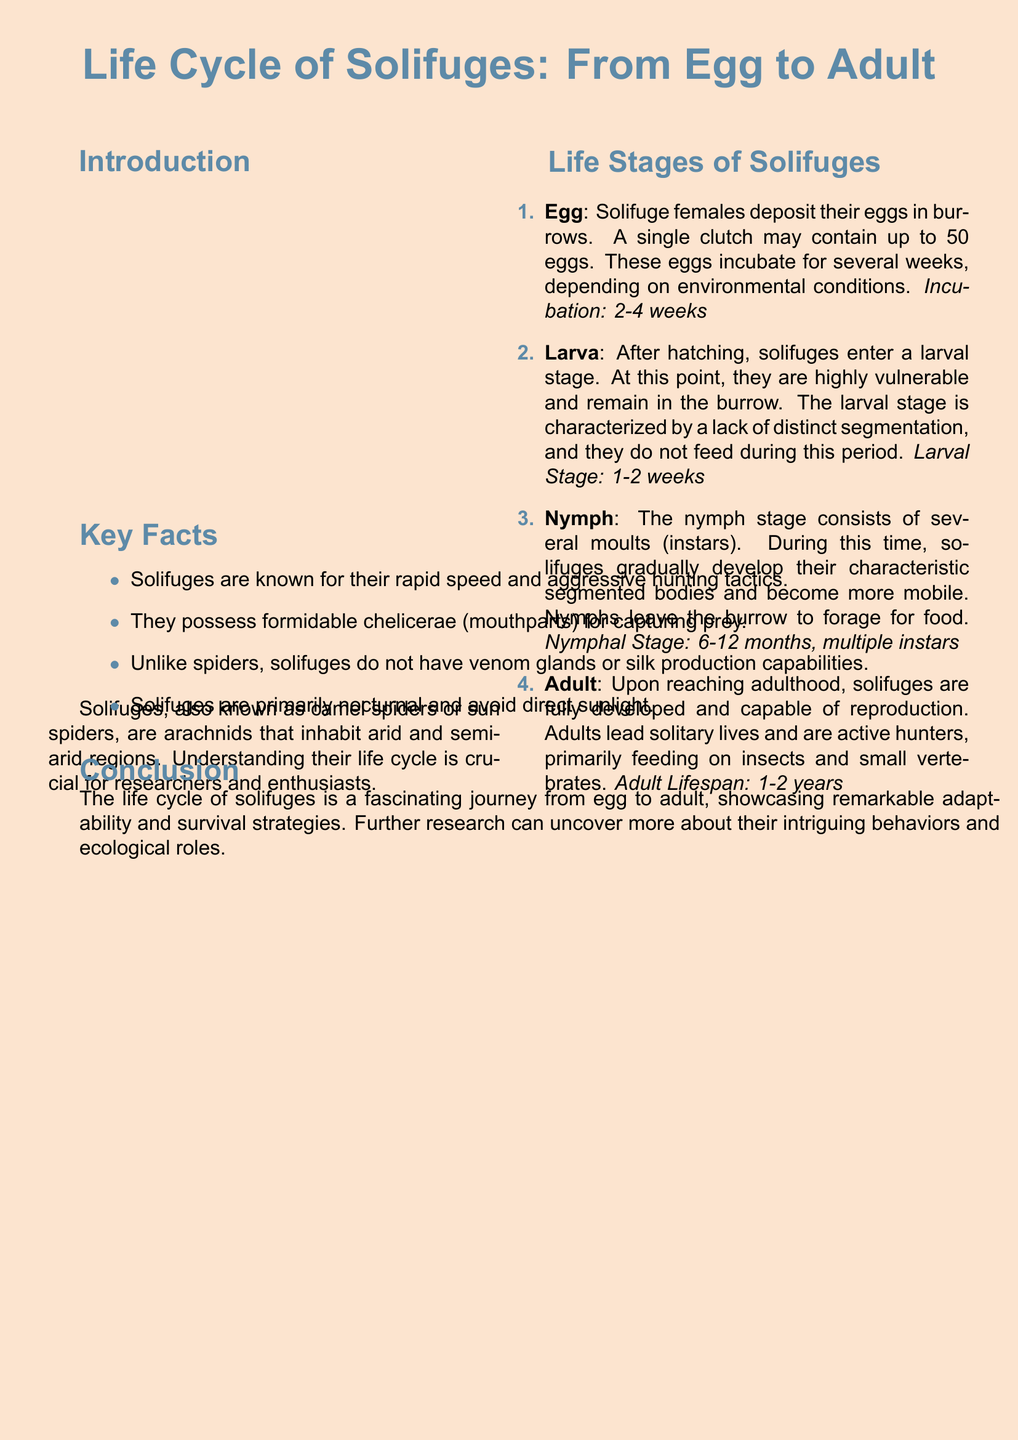what is the incubating period for solifuge eggs? The document states that the incubation period for solifuge eggs is 2-4 weeks.
Answer: 2-4 weeks how many eggs can a solifuge female lay in one clutch? According to the flyer, a single clutch may contain up to 50 eggs.
Answer: 50 eggs what is the larval stage duration for solifuges? The larval stage lasts for 1-2 weeks as mentioned in the document.
Answer: 1-2 weeks what do solifuge nymphs do during their stage? Nymphs leave the burrow to forage for food as indicated in the flyer.
Answer: Forage for food how long is the lifespan of an adult solifuge? The document notes that the adult lifespan is 1-2 years.
Answer: 1-2 years which term describes solifuges' hunting behavior? The flyer mentions that solifuges are known for their rapid speed and aggressive hunting tactics.
Answer: Aggressive hunting tactics how do solifuges differ from spiders in terms of venom? The document states that unlike spiders, solifuges do not have venom glands.
Answer: Do not have venom glands what stage comes after the larva in a solifuge's life cycle? The document indicates that the stage after larva is the nymph stage.
Answer: Nymph what characteristic do solifuges develop during the nymph stage? The flyer describes that solifuges gradually develop their characteristic segmented bodies during the nymph stage.
Answer: Segmented bodies 